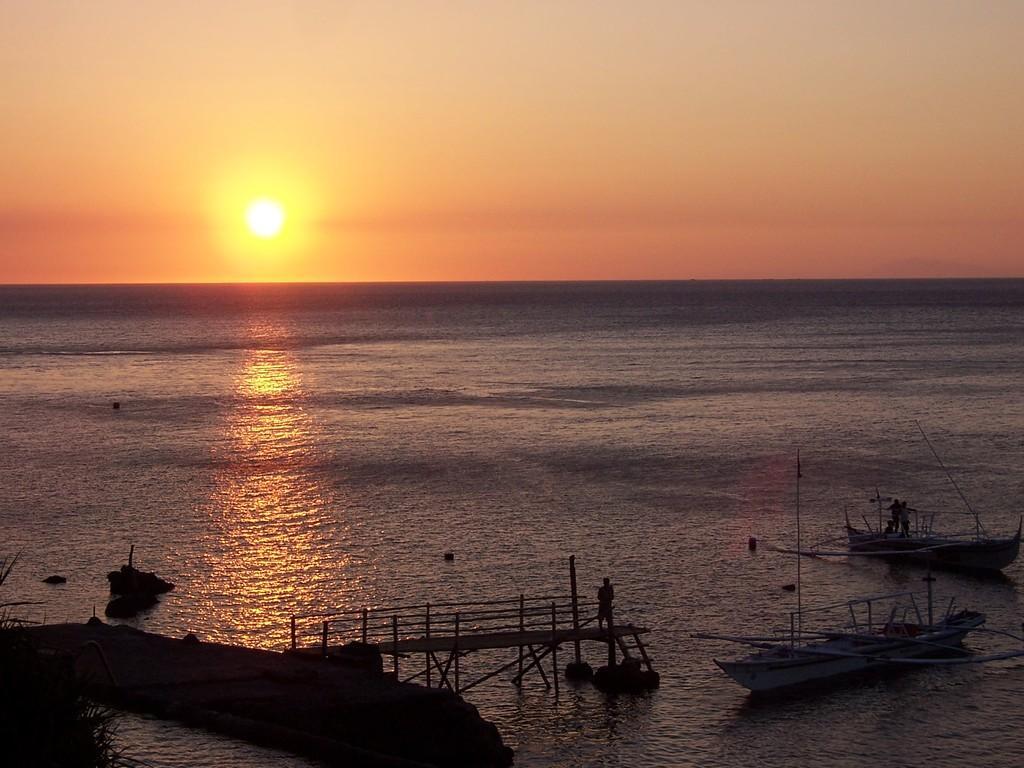In one or two sentences, can you explain what this image depicts? In this picture, I can see a ocean after that a sun, sky, two boats and people standing on it. 